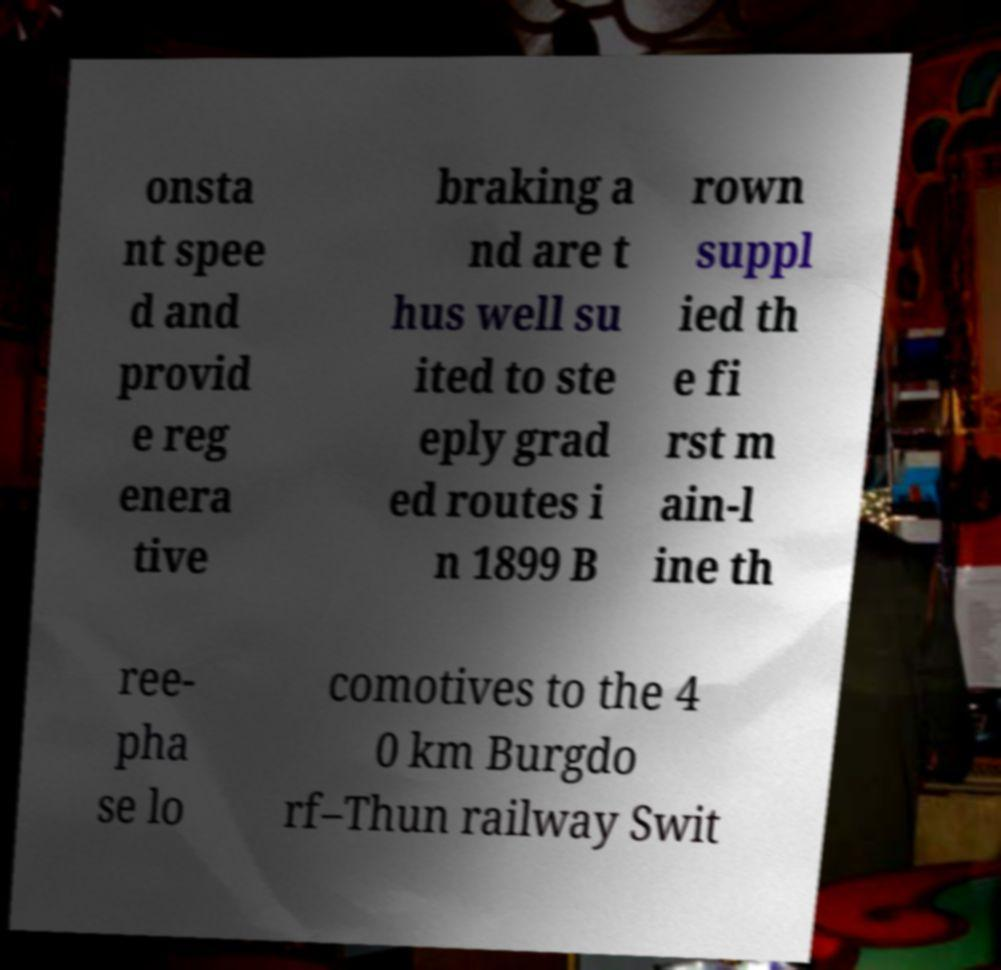Can you accurately transcribe the text from the provided image for me? onsta nt spee d and provid e reg enera tive braking a nd are t hus well su ited to ste eply grad ed routes i n 1899 B rown suppl ied th e fi rst m ain-l ine th ree- pha se lo comotives to the 4 0 km Burgdo rf–Thun railway Swit 